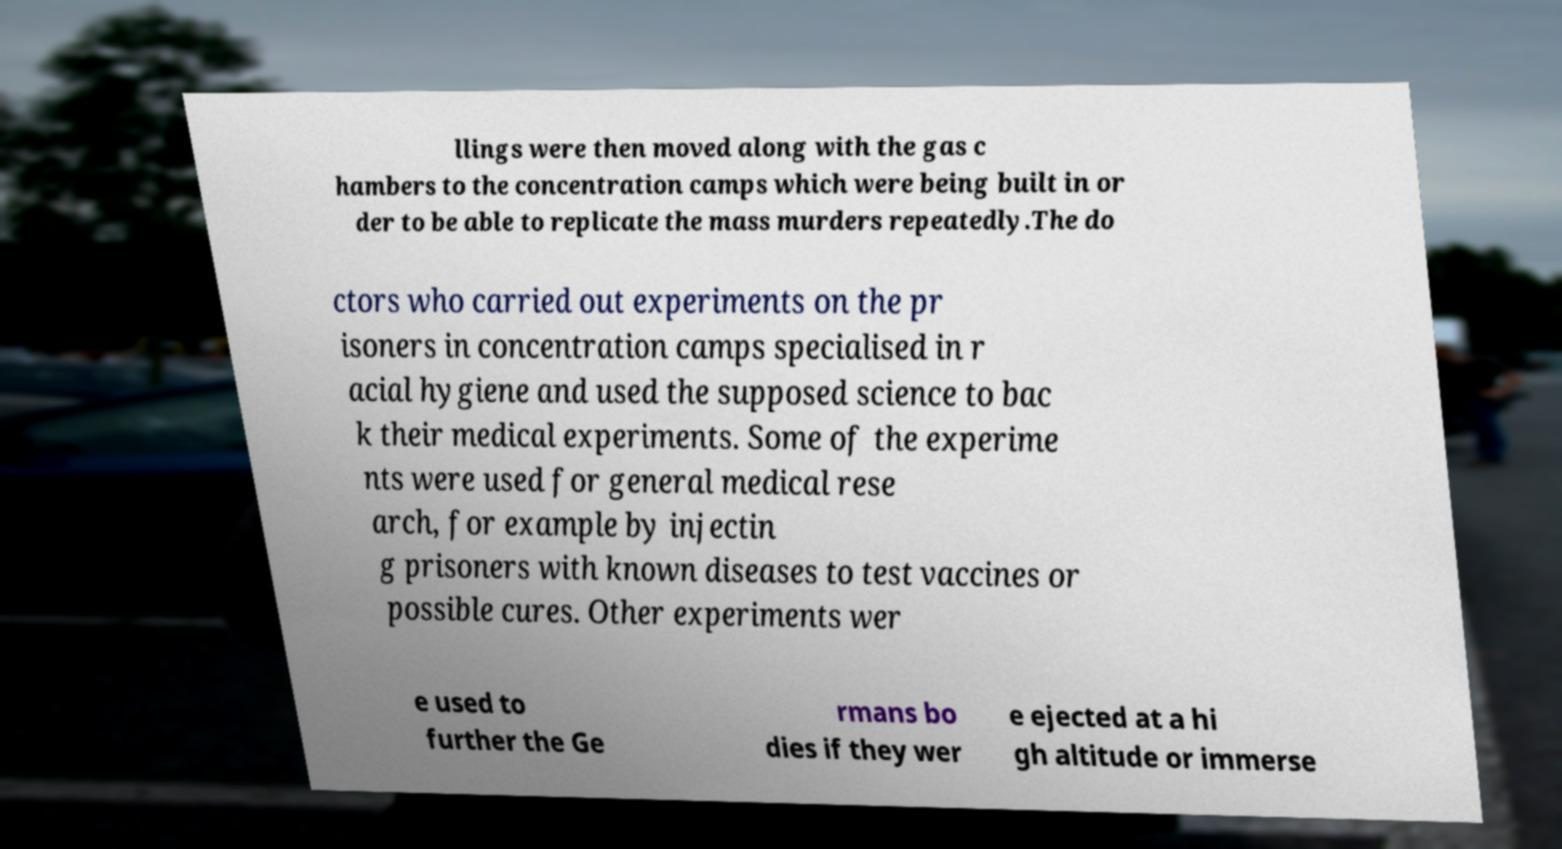I need the written content from this picture converted into text. Can you do that? llings were then moved along with the gas c hambers to the concentration camps which were being built in or der to be able to replicate the mass murders repeatedly.The do ctors who carried out experiments on the pr isoners in concentration camps specialised in r acial hygiene and used the supposed science to bac k their medical experiments. Some of the experime nts were used for general medical rese arch, for example by injectin g prisoners with known diseases to test vaccines or possible cures. Other experiments wer e used to further the Ge rmans bo dies if they wer e ejected at a hi gh altitude or immerse 